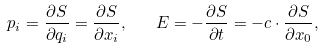<formula> <loc_0><loc_0><loc_500><loc_500>p _ { i } = { \frac { \partial S } { \partial q _ { i } } } = { \frac { \partial S } { \partial x _ { i } } } , \quad E = - { \frac { \partial S } { \partial t } } = - c \cdot { \frac { \partial S } { \partial x _ { 0 } } } ,</formula> 